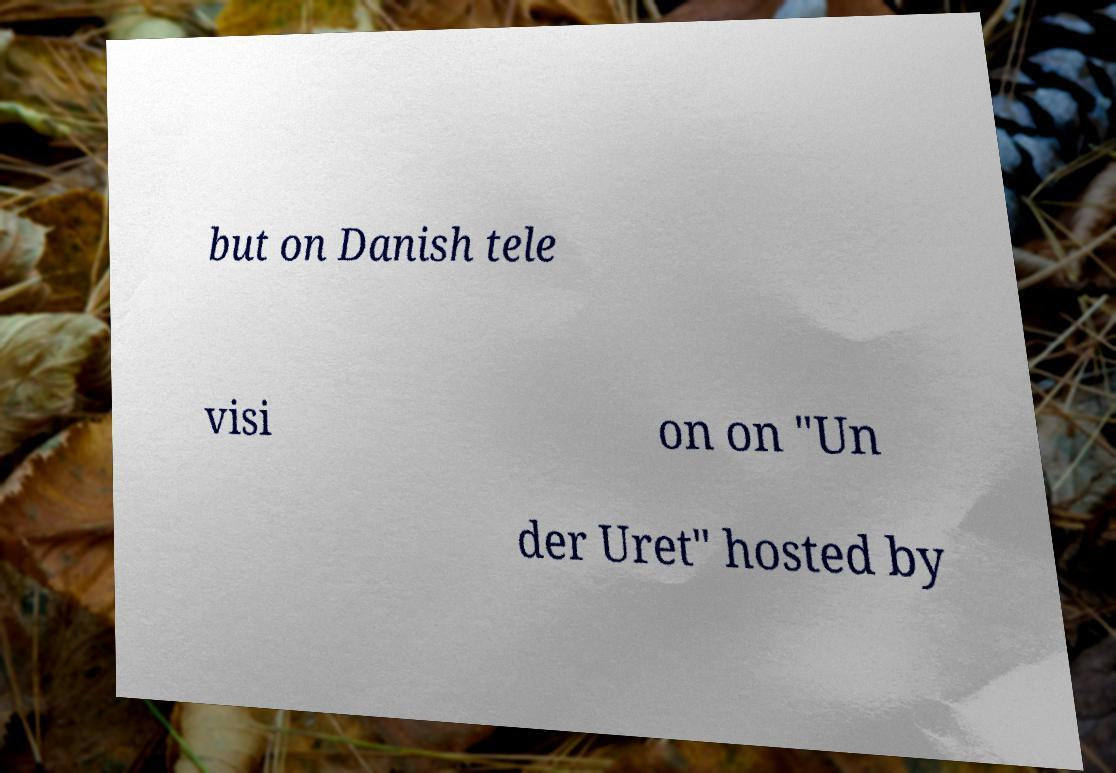I need the written content from this picture converted into text. Can you do that? but on Danish tele visi on on "Un der Uret" hosted by 